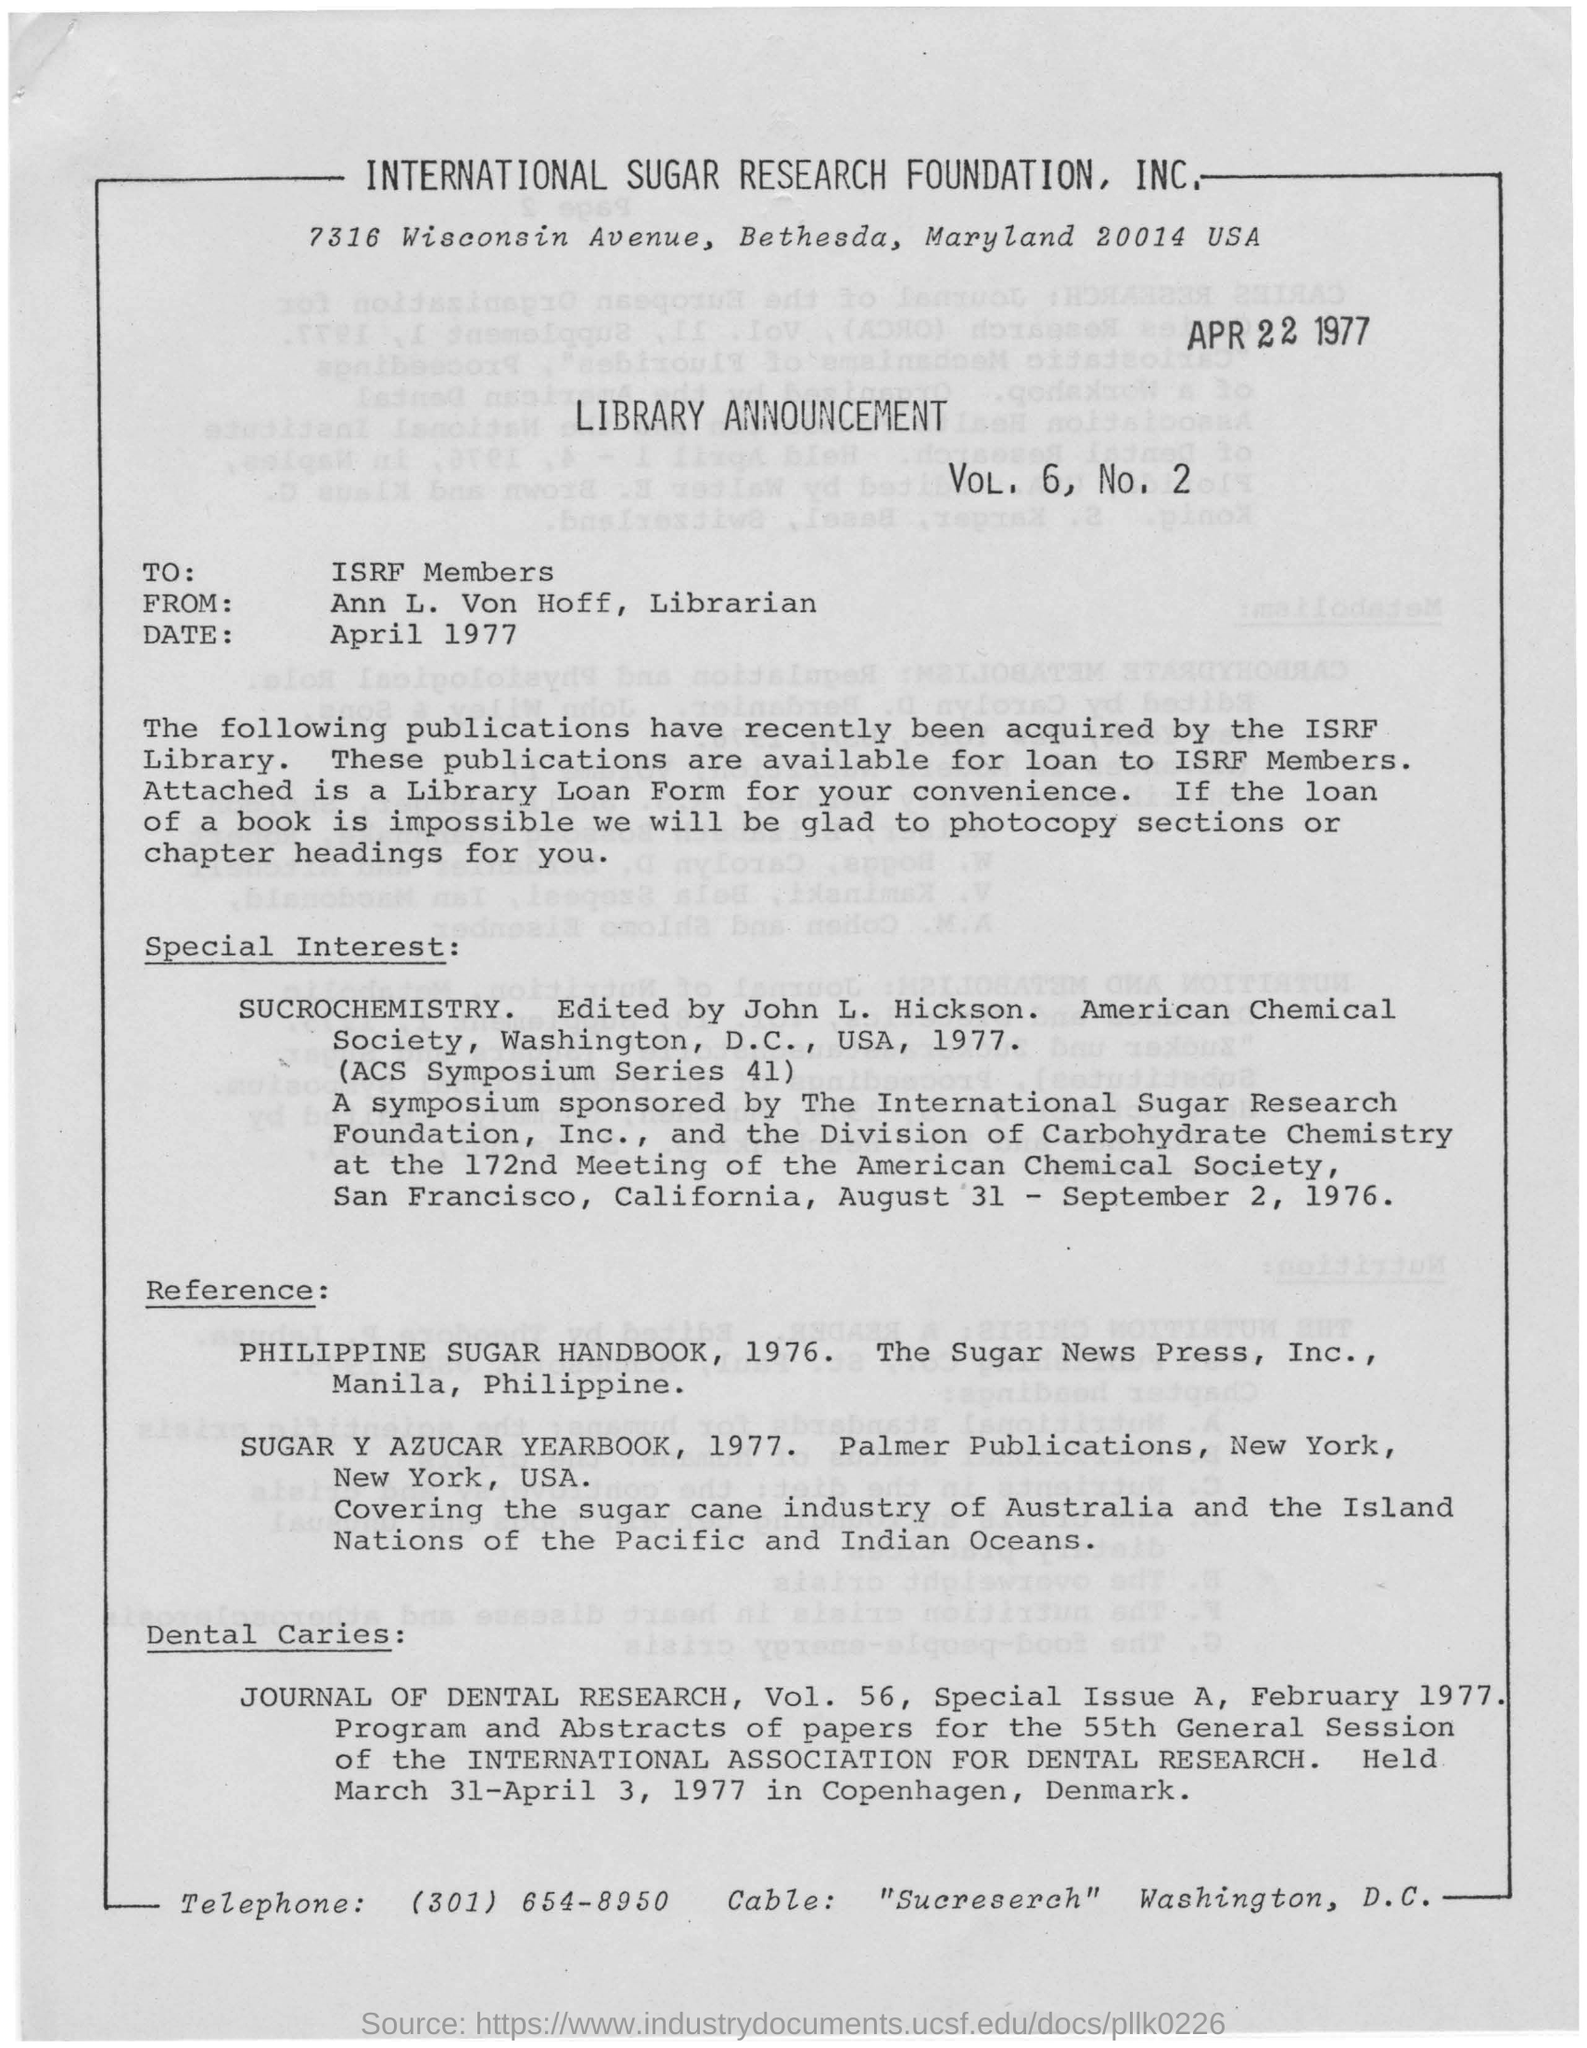Draw attention to some important aspects in this diagram. Ann L. Von Hoff is the Librarian. The person who edited the "SUCROCHEMISTRY" was John L. Hickson. The announcement is directed towards the ISRF members. The International Association for Dental Research was held in Copenhagen, Denmark. 